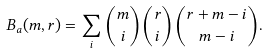Convert formula to latex. <formula><loc_0><loc_0><loc_500><loc_500>B _ { a } ( m , r ) = \sum _ { i } \binom { m } { i } \binom { r } { i } \binom { r + m - i } { m - i } .</formula> 